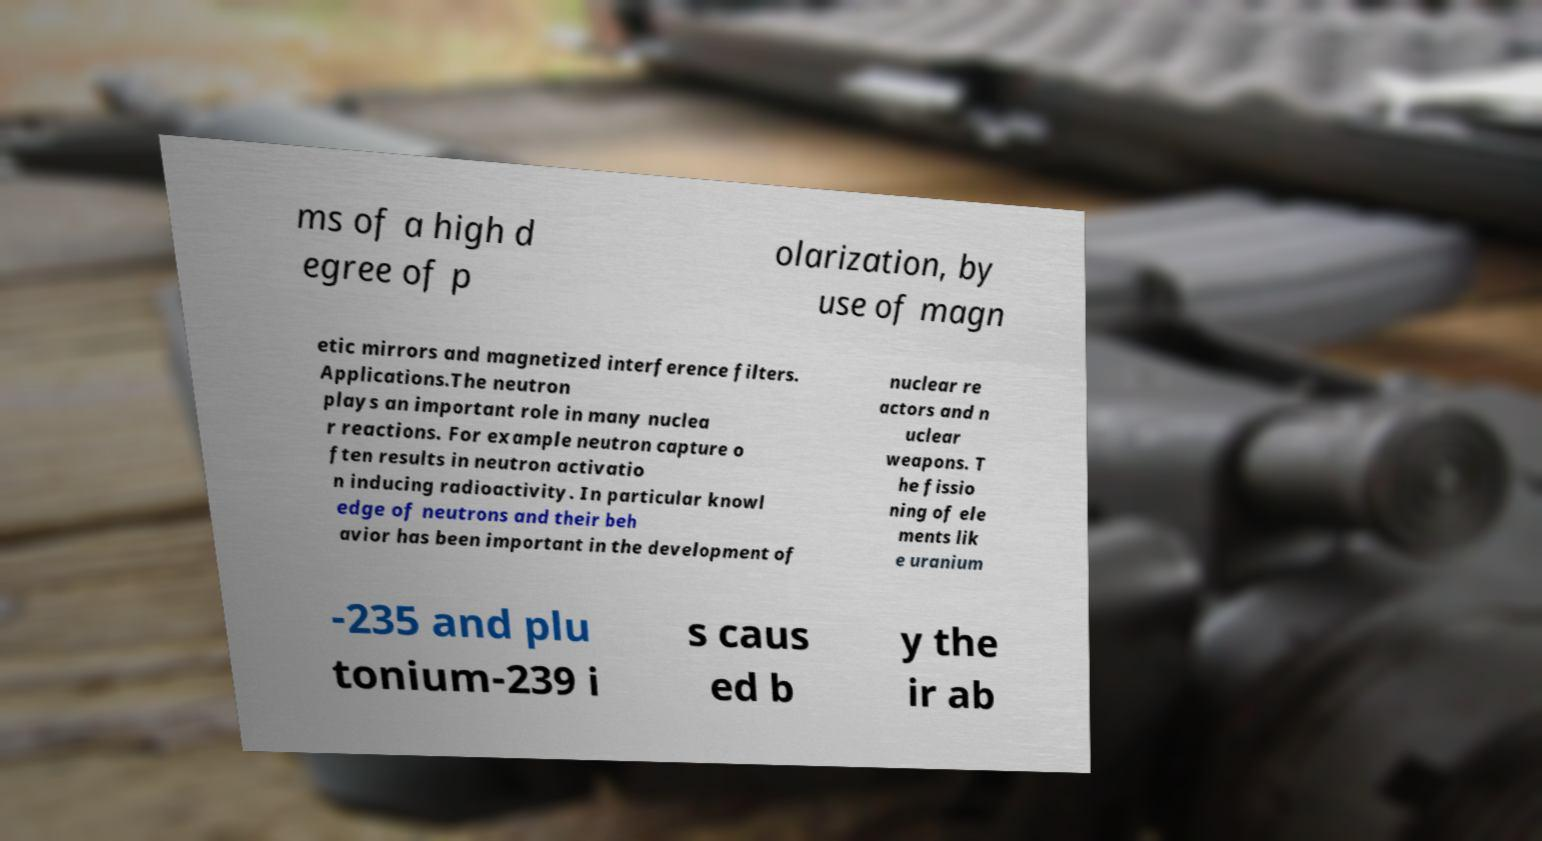Can you read and provide the text displayed in the image?This photo seems to have some interesting text. Can you extract and type it out for me? ms of a high d egree of p olarization, by use of magn etic mirrors and magnetized interference filters. Applications.The neutron plays an important role in many nuclea r reactions. For example neutron capture o ften results in neutron activatio n inducing radioactivity. In particular knowl edge of neutrons and their beh avior has been important in the development of nuclear re actors and n uclear weapons. T he fissio ning of ele ments lik e uranium -235 and plu tonium-239 i s caus ed b y the ir ab 